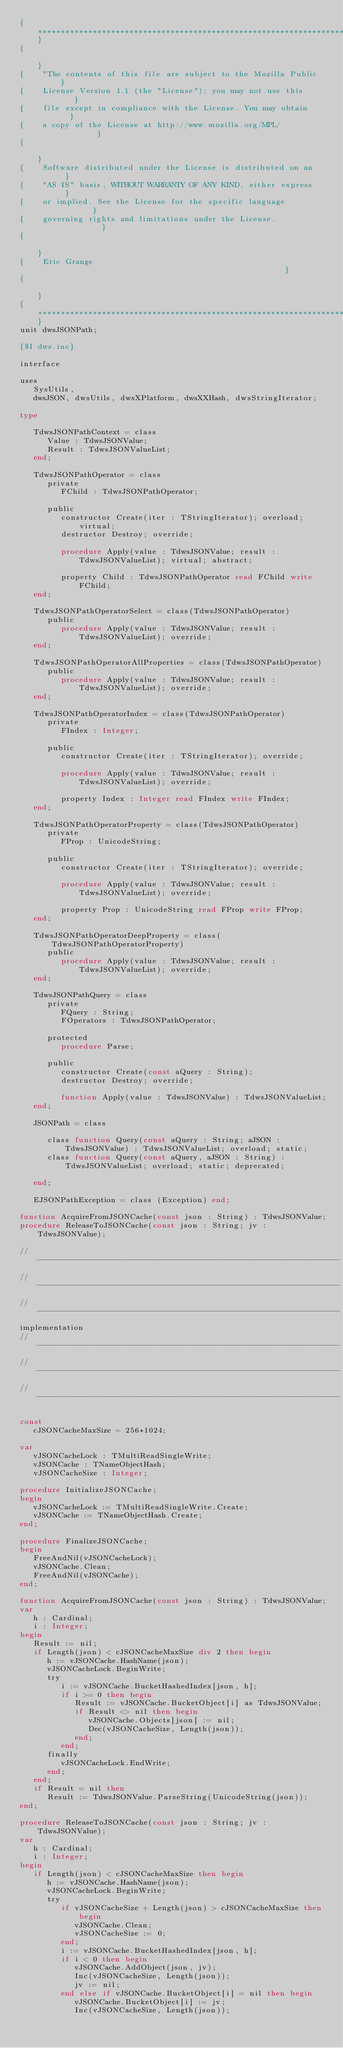<code> <loc_0><loc_0><loc_500><loc_500><_Pascal_>{**********************************************************************}
{                                                                      }
{    "The contents of this file are subject to the Mozilla Public      }
{    License Version 1.1 (the "License"); you may not use this         }
{    file except in compliance with the License. You may obtain        }
{    a copy of the License at http://www.mozilla.org/MPL/              }
{                                                                      }
{    Software distributed under the License is distributed on an       }
{    "AS IS" basis, WITHOUT WARRANTY OF ANY KIND, either express       }
{    or implied. See the License for the specific language             }
{    governing rights and limitations under the License.               }
{                                                                      }
{    Eric Grange                                                       }
{                                                                      }
{**********************************************************************}
unit dwsJSONPath;

{$I dws.inc}

interface

uses
   SysUtils,
   dwsJSON, dwsUtils, dwsXPlatform, dwsXXHash, dwsStringIterator;

type

   TdwsJSONPathContext = class
      Value : TdwsJSONValue;
      Result : TdwsJSONValueList;
   end;

   TdwsJSONPathOperator = class
      private
         FChild : TdwsJSONPathOperator;

      public
         constructor Create(iter : TStringIterator); overload; virtual;
         destructor Destroy; override;

         procedure Apply(value : TdwsJSONValue; result : TdwsJSONValueList); virtual; abstract;

         property Child : TdwsJSONPathOperator read FChild write FChild;
   end;

   TdwsJSONPathOperatorSelect = class(TdwsJSONPathOperator)
      public
         procedure Apply(value : TdwsJSONValue; result : TdwsJSONValueList); override;
   end;

   TdwsJSONPathOperatorAllProperties = class(TdwsJSONPathOperator)
      public
         procedure Apply(value : TdwsJSONValue; result : TdwsJSONValueList); override;
   end;

   TdwsJSONPathOperatorIndex = class(TdwsJSONPathOperator)
      private
         FIndex : Integer;

      public
         constructor Create(iter : TStringIterator); override;

         procedure Apply(value : TdwsJSONValue; result : TdwsJSONValueList); override;

         property Index : Integer read FIndex write FIndex;
   end;

   TdwsJSONPathOperatorProperty = class(TdwsJSONPathOperator)
      private
         FProp : UnicodeString;

      public
         constructor Create(iter : TStringIterator); override;

         procedure Apply(value : TdwsJSONValue; result : TdwsJSONValueList); override;

         property Prop : UnicodeString read FProp write FProp;
   end;

   TdwsJSONPathOperatorDeepProperty = class(TdwsJSONPathOperatorProperty)
      public
         procedure Apply(value : TdwsJSONValue; result : TdwsJSONValueList); override;
   end;

   TdwsJSONPathQuery = class
      private
         FQuery : String;
         FOperators : TdwsJSONPathOperator;

      protected
         procedure Parse;

      public
         constructor Create(const aQuery : String);
         destructor Destroy; override;

         function Apply(value : TdwsJSONValue) : TdwsJSONValueList;
   end;

   JSONPath = class

      class function Query(const aQuery : String; aJSON : TdwsJSONValue) : TdwsJSONValueList; overload; static;
      class function Query(const aQuery, aJSON : String) : TdwsJSONValueList; overload; static; deprecated;

   end;

   EJSONPathException = class (Exception) end;

function AcquireFromJSONCache(const json : String) : TdwsJSONValue;
procedure ReleaseToJSONCache(const json : String; jv : TdwsJSONValue);

// ------------------------------------------------------------------
// ------------------------------------------------------------------
// ------------------------------------------------------------------
implementation
// ------------------------------------------------------------------
// ------------------------------------------------------------------
// ------------------------------------------------------------------

const
   cJSONCacheMaxSize = 256*1024;

var
   vJSONCacheLock : TMultiReadSingleWrite;
   vJSONCache : TNameObjectHash;
   vJSONCacheSize : Integer;

procedure InitializeJSONCache;
begin
   vJSONCacheLock := TMultiReadSingleWrite.Create;
   vJSONCache := TNameObjectHash.Create;
end;

procedure FinalizeJSONCache;
begin
   FreeAndNil(vJSONCacheLock);
   vJSONCache.Clean;
   FreeAndNil(vJSONCache);
end;

function AcquireFromJSONCache(const json : String) : TdwsJSONValue;
var
   h : Cardinal;
   i : Integer;
begin
   Result := nil;
   if Length(json) < cJSONCacheMaxSize div 2 then begin
      h := vJSONCache.HashName(json);
      vJSONCacheLock.BeginWrite;
      try
         i := vJSONCache.BucketHashedIndex[json, h];
         if i >= 0 then begin
            Result := vJSONCache.BucketObject[i] as TdwsJSONValue;
            if Result <> nil then begin
               vJSONCache.Objects[json] := nil;
               Dec(vJSONCacheSize, Length(json));
            end;
         end;
      finally
         vJSONCacheLock.EndWrite;
      end;
   end;
   if Result = nil then
      Result := TdwsJSONValue.ParseString(UnicodeString(json));
end;

procedure ReleaseToJSONCache(const json : String; jv : TdwsJSONValue);
var
   h : Cardinal;
   i : Integer;
begin
   if Length(json) < cJSONCacheMaxSize then begin
      h := vJSONCache.HashName(json);
      vJSONCacheLock.BeginWrite;
      try
         if vJSONCacheSize + Length(json) > cJSONCacheMaxSize then begin
            vJSONCache.Clean;
            vJSONCacheSize := 0;
         end;
         i := vJSONCache.BucketHashedIndex[json, h];
         if i < 0 then begin
            vJSONCache.AddObject(json, jv);
            Inc(vJSONCacheSize, Length(json));
            jv := nil;
         end else if vJSONCache.BucketObject[i] = nil then begin
            vJSONCache.BucketObject[i] := jv;
            Inc(vJSONCacheSize, Length(json));</code> 